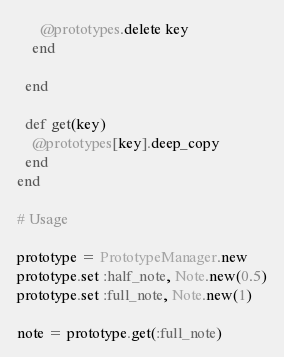Convert code to text. <code><loc_0><loc_0><loc_500><loc_500><_Ruby_>      @prototypes.delete key
    end

  end

  def get(key)
    @prototypes[key].deep_copy
  end
end

# Usage

prototype = PrototypeManager.new
prototype.set :half_note, Note.new(0.5)
prototype.set :full_note, Note.new(1)

note = prototype.get(:full_note)

</code> 